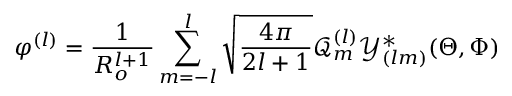<formula> <loc_0><loc_0><loc_500><loc_500>\varphi ^ { ( l ) } = \frac { 1 } { R _ { o } ^ { l + 1 } } \sum _ { m = - l } ^ { l } \sqrt { \frac { 4 \pi } { 2 l + 1 } } \mathcal { Q } _ { m } ^ { ( l ) } \mathcal { Y } _ { ( l m ) } ^ { * } ( \Theta , \Phi )</formula> 